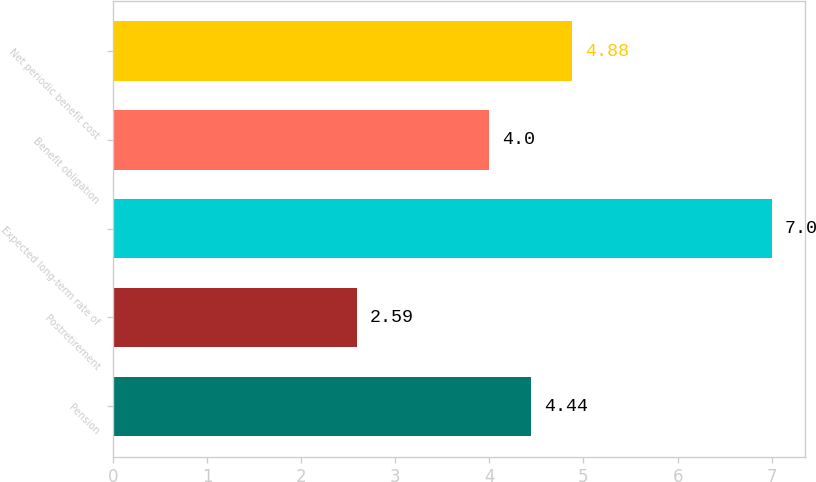Convert chart to OTSL. <chart><loc_0><loc_0><loc_500><loc_500><bar_chart><fcel>Pension<fcel>Postretirement<fcel>Expected long-term rate of<fcel>Benefit obligation<fcel>Net periodic benefit cost<nl><fcel>4.44<fcel>2.59<fcel>7<fcel>4<fcel>4.88<nl></chart> 